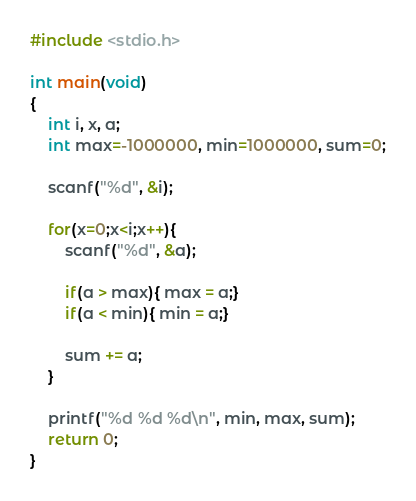Convert code to text. <code><loc_0><loc_0><loc_500><loc_500><_C_>#include <stdio.h>
 
int main(void)
{
    int i, x, a;
    int max=-1000000, min=1000000, sum=0;
 
    scanf("%d", &i);
 
    for(x=0;x<i;x++){
        scanf("%d", &a);
     
        if(a > max){ max = a;}
        if(a < min){ min = a;}
         
        sum += a;
    }
 
    printf("%d %d %d\n", min, max, sum);
    return 0;
}  </code> 